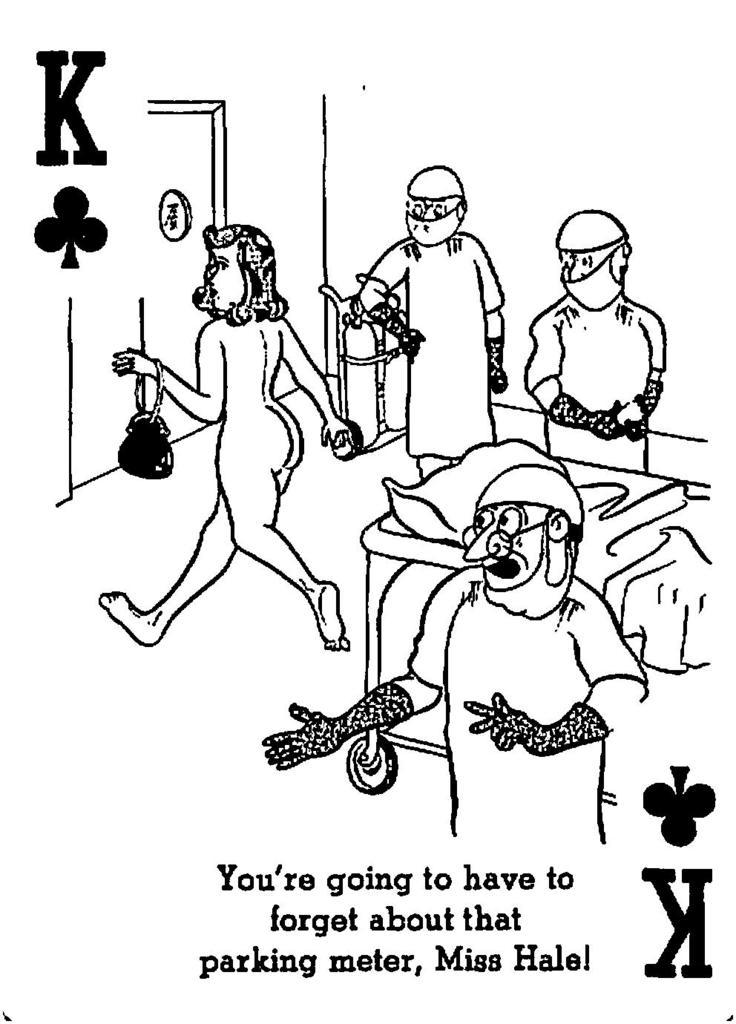What types of people are depicted in the image? The image contains images of women and men. What objects are present in the image that might be used for medical purposes? There is a stretcher in the image, which could be used for medical purposes. What object in the image might be used for comfort or support? There is a pillow in the image, which could be used for comfort or support. What shape is the object in the image that is not a stretcher or pillow? There is a cylinder in the image, which has a cylindrical shape. What type of grape is being sold on the sidewalk in the image? There is no sidewalk or grape present in the image. What news is being reported in the image? There is no news or news source present in the image. 